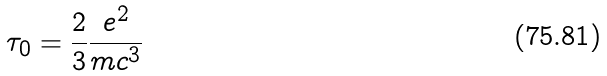Convert formula to latex. <formula><loc_0><loc_0><loc_500><loc_500>\tau _ { 0 } = \frac { 2 } { 3 } \frac { e ^ { 2 } } { m c ^ { 3 } }</formula> 